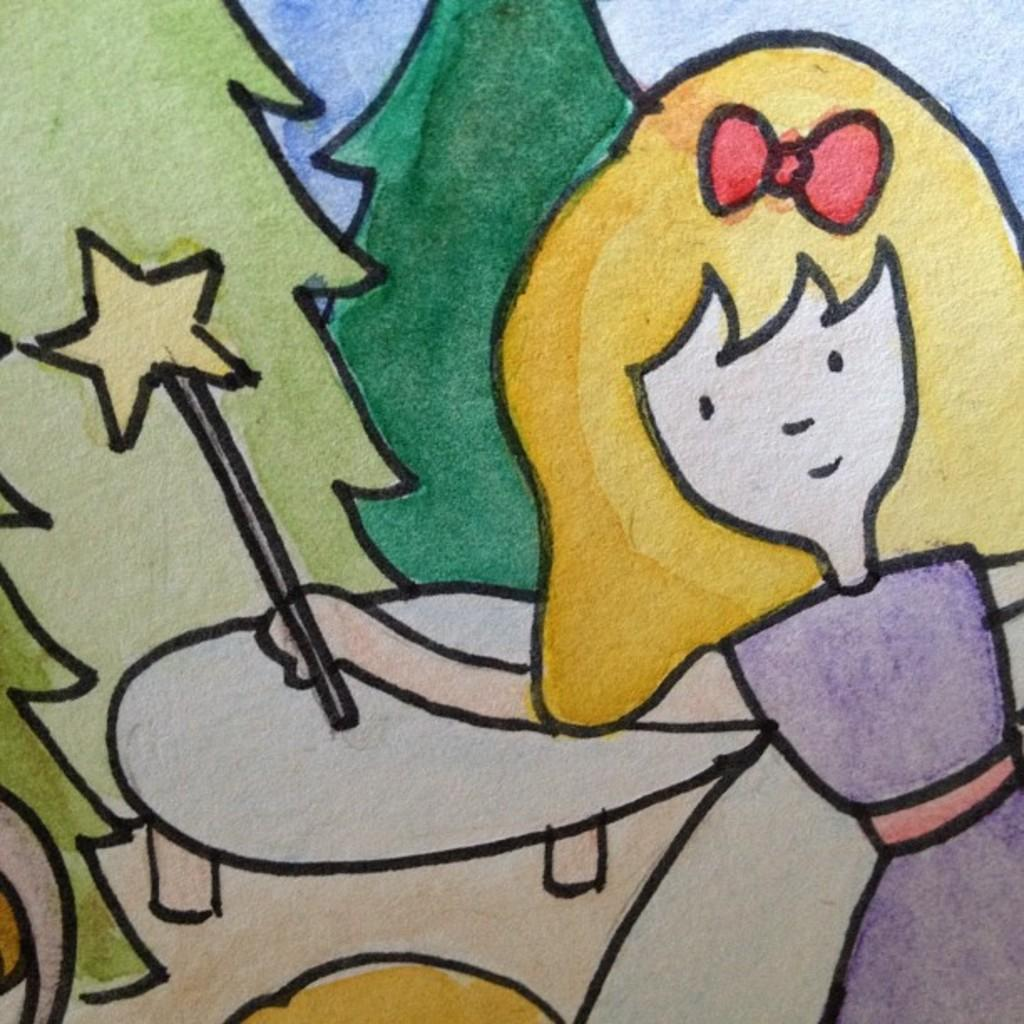What is the main subject of the picture? The main subject of the picture is a drawing. What is being depicted in the drawing? The drawing depicts trees and a girl holding an object. What else can be seen in the drawing? The drawing also depicts a table. How many bottles are visible on the table in the drawing? There are no bottles visible on the table in the drawing; the drawing only depicts a girl holding an object and trees. 